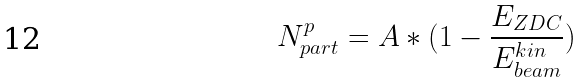<formula> <loc_0><loc_0><loc_500><loc_500>N _ { p a r t } ^ { p } = A * ( 1 - \frac { E _ { Z D C } } { E _ { b e a m } ^ { k i n } } )</formula> 